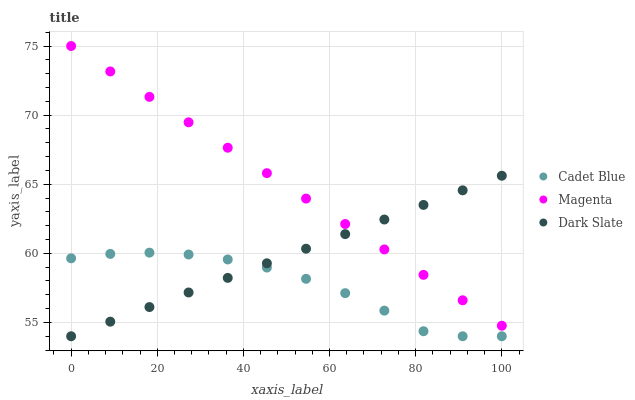Does Cadet Blue have the minimum area under the curve?
Answer yes or no. Yes. Does Magenta have the maximum area under the curve?
Answer yes or no. Yes. Does Magenta have the minimum area under the curve?
Answer yes or no. No. Does Cadet Blue have the maximum area under the curve?
Answer yes or no. No. Is Magenta the smoothest?
Answer yes or no. Yes. Is Cadet Blue the roughest?
Answer yes or no. Yes. Is Cadet Blue the smoothest?
Answer yes or no. No. Is Magenta the roughest?
Answer yes or no. No. Does Dark Slate have the lowest value?
Answer yes or no. Yes. Does Magenta have the lowest value?
Answer yes or no. No. Does Magenta have the highest value?
Answer yes or no. Yes. Does Cadet Blue have the highest value?
Answer yes or no. No. Is Cadet Blue less than Magenta?
Answer yes or no. Yes. Is Magenta greater than Cadet Blue?
Answer yes or no. Yes. Does Dark Slate intersect Cadet Blue?
Answer yes or no. Yes. Is Dark Slate less than Cadet Blue?
Answer yes or no. No. Is Dark Slate greater than Cadet Blue?
Answer yes or no. No. Does Cadet Blue intersect Magenta?
Answer yes or no. No. 